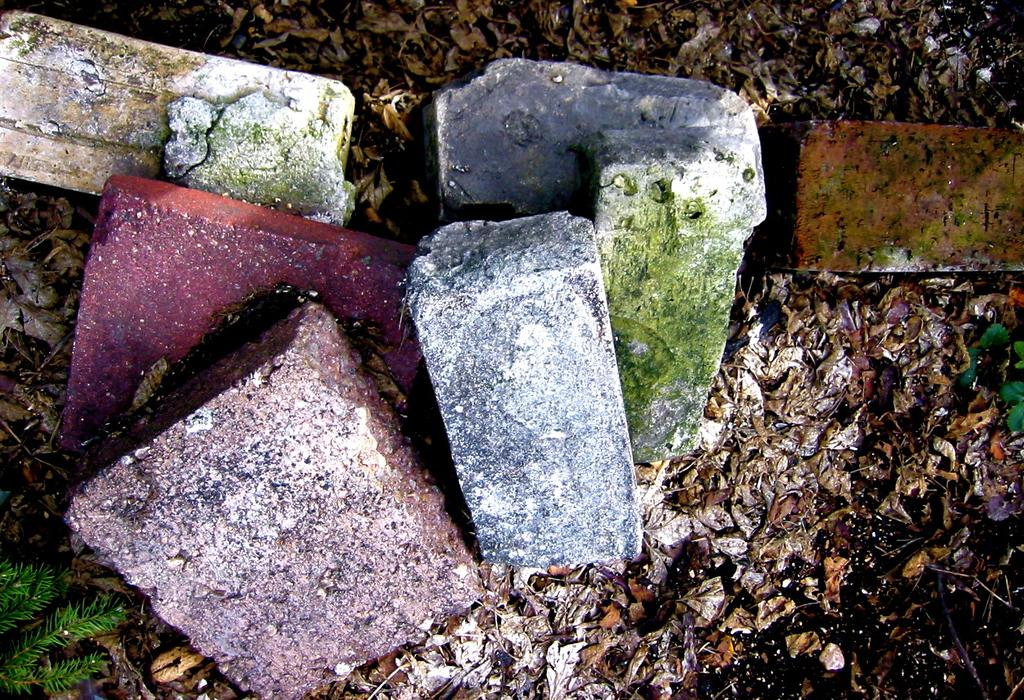What type of material is featured in the image? The image contains colorful bricks. Can you describe the appearance of the bricks? The bricks are colorful, which suggests they may have different hues or patterns. How does the image show an increase in the number of insects? The image does not show an increase in the number of insects; it only contains colorful bricks. What type of beast can be seen interacting with the bricks in the image? There is no beast present in the image; it only contains colorful bricks. 